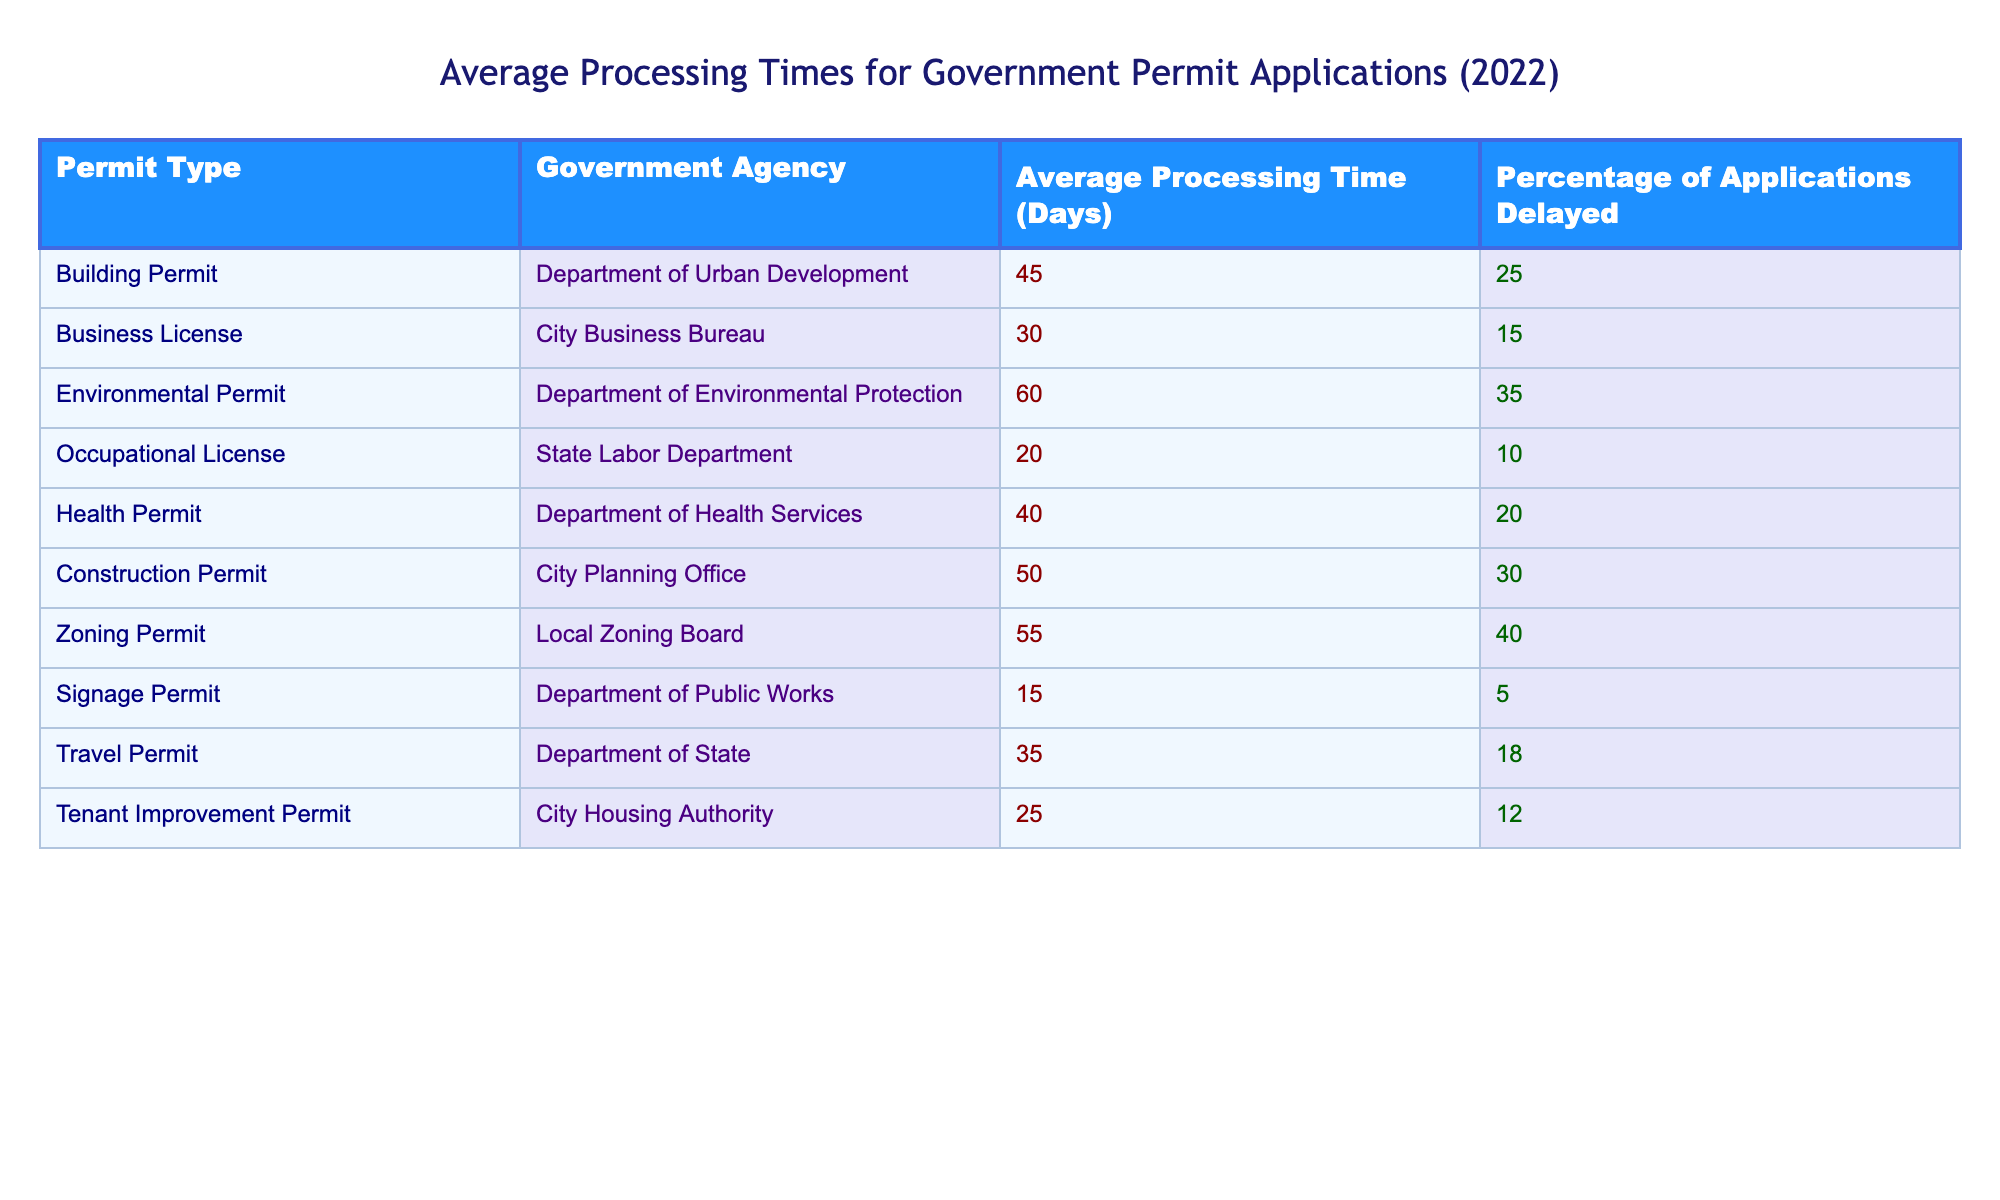What is the average processing time for a Health Permit? The table indicates that the average processing time for a Health Permit is given in the corresponding row for this permit type. It states that the average processing time is 40 days.
Answer: 40 days Which permit type has the highest percentage of applications delayed? By examining the 'Percentage of Applications Delayed' column, Environmental Permit stands out with a percentage of 35%, which is higher than any other permit type.
Answer: Environmental Permit Calculate the difference between the average processing time of the Environmental Permit and the Occupational License. The average processing time for the Environmental Permit is 60 days, and for the Occupational License, it is 20 days. The difference is calculated by subtracting the two values: 60 - 20 = 40 days.
Answer: 40 days Is the average processing time for a Business License shorter than that for a Construction Permit? Looking at the table, the average processing time for a Business License is 30 days, while for a Construction Permit it is 50 days. Since 30 is less than 50, the answer is yes.
Answer: Yes What is the average processing time for all permit types listed? First, sum the average processing times for each permit: 45 + 30 + 60 + 20 + 40 + 50 + 55 + 15 + 35 + 25 =  430 days. Then, divide by the number of permit types (10), resulting in an average of 43 days.
Answer: 43 days What is the percentage of applications delayed for the Zoning Permit? The table shows that the percentage of applications delayed for the Zoning Permit is 40%. This value is directly stated in the corresponding row for this permit type.
Answer: 40% Among all permits, which type has the shortest average processing time and how long is it? By reviewing the 'Average Processing Time' column, we find the shortest processing time is listed for the Signage Permit at 15 days.
Answer: Signage Permit, 15 days If the average processing time for a Building Permit is compared with the average of the Health Permit and Signage Permit, which is higher? The Building Permit has a processing time of 45 days. The average of the Health Permit (40 days) and Signage Permit (15 days) is (40 + 15) / 2 = 27.5 days. Since 45 is greater than 27.5, the Building Permit is higher.
Answer: Building Permit How many permit types have an average processing time greater than 50 days? By examining the 'Average Processing Time' column, the Environmental Permit (60), Zoning Permit (55), and Construction Permit (50) are the only types exceeding 50 days. That makes a total of 3 permit types.
Answer: 3 